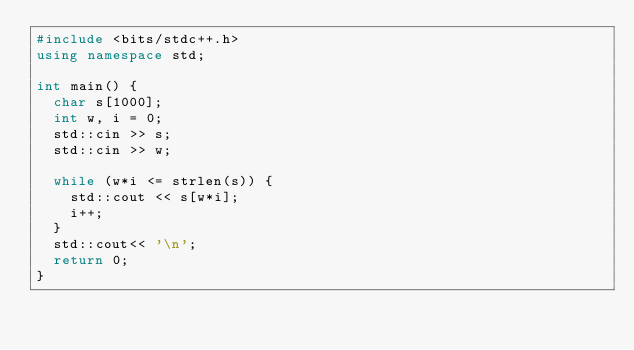<code> <loc_0><loc_0><loc_500><loc_500><_C++_>#include <bits/stdc++.h>
using namespace std;

int main() {
  char s[1000];
  int w, i = 0;
  std::cin >> s;
  std::cin >> w;

  while (w*i <= strlen(s)) {
    std::cout << s[w*i];
    i++;
  }
  std::cout<< '\n';
  return 0;
}
</code> 